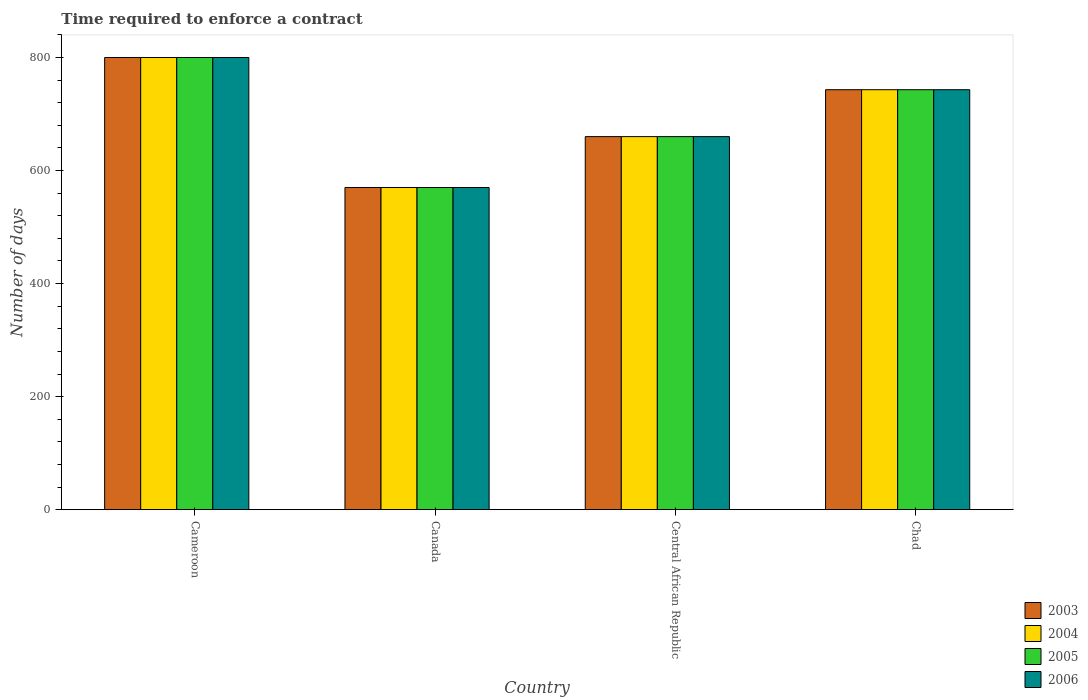How many different coloured bars are there?
Make the answer very short. 4. How many groups of bars are there?
Provide a short and direct response. 4. How many bars are there on the 4th tick from the right?
Provide a short and direct response. 4. What is the label of the 1st group of bars from the left?
Offer a terse response. Cameroon. What is the number of days required to enforce a contract in 2004 in Cameroon?
Provide a succinct answer. 800. Across all countries, what is the maximum number of days required to enforce a contract in 2003?
Give a very brief answer. 800. Across all countries, what is the minimum number of days required to enforce a contract in 2006?
Ensure brevity in your answer.  570. In which country was the number of days required to enforce a contract in 2005 maximum?
Your answer should be very brief. Cameroon. In which country was the number of days required to enforce a contract in 2005 minimum?
Your response must be concise. Canada. What is the total number of days required to enforce a contract in 2006 in the graph?
Ensure brevity in your answer.  2773. What is the difference between the number of days required to enforce a contract in 2006 in Canada and that in Central African Republic?
Keep it short and to the point. -90. What is the difference between the number of days required to enforce a contract in 2003 in Central African Republic and the number of days required to enforce a contract in 2005 in Cameroon?
Give a very brief answer. -140. What is the average number of days required to enforce a contract in 2006 per country?
Keep it short and to the point. 693.25. In how many countries, is the number of days required to enforce a contract in 2004 greater than 560 days?
Offer a terse response. 4. What is the ratio of the number of days required to enforce a contract in 2005 in Cameroon to that in Chad?
Offer a very short reply. 1.08. Is the difference between the number of days required to enforce a contract in 2006 in Cameroon and Canada greater than the difference between the number of days required to enforce a contract in 2004 in Cameroon and Canada?
Your answer should be very brief. No. What is the difference between the highest and the second highest number of days required to enforce a contract in 2005?
Keep it short and to the point. 140. What is the difference between the highest and the lowest number of days required to enforce a contract in 2006?
Your answer should be very brief. 230. In how many countries, is the number of days required to enforce a contract in 2003 greater than the average number of days required to enforce a contract in 2003 taken over all countries?
Ensure brevity in your answer.  2. Is the sum of the number of days required to enforce a contract in 2006 in Cameroon and Chad greater than the maximum number of days required to enforce a contract in 2003 across all countries?
Your response must be concise. Yes. Is it the case that in every country, the sum of the number of days required to enforce a contract in 2003 and number of days required to enforce a contract in 2004 is greater than the sum of number of days required to enforce a contract in 2006 and number of days required to enforce a contract in 2005?
Your answer should be compact. No. What does the 4th bar from the right in Canada represents?
Offer a very short reply. 2003. How many bars are there?
Your answer should be very brief. 16. Are all the bars in the graph horizontal?
Make the answer very short. No. How many countries are there in the graph?
Your answer should be very brief. 4. Does the graph contain grids?
Provide a short and direct response. No. How many legend labels are there?
Offer a very short reply. 4. What is the title of the graph?
Make the answer very short. Time required to enforce a contract. Does "1986" appear as one of the legend labels in the graph?
Offer a terse response. No. What is the label or title of the Y-axis?
Your answer should be very brief. Number of days. What is the Number of days in 2003 in Cameroon?
Your response must be concise. 800. What is the Number of days in 2004 in Cameroon?
Your answer should be compact. 800. What is the Number of days of 2005 in Cameroon?
Offer a very short reply. 800. What is the Number of days of 2006 in Cameroon?
Offer a terse response. 800. What is the Number of days in 2003 in Canada?
Your answer should be compact. 570. What is the Number of days of 2004 in Canada?
Offer a terse response. 570. What is the Number of days in 2005 in Canada?
Provide a succinct answer. 570. What is the Number of days in 2006 in Canada?
Provide a short and direct response. 570. What is the Number of days of 2003 in Central African Republic?
Provide a short and direct response. 660. What is the Number of days of 2004 in Central African Republic?
Ensure brevity in your answer.  660. What is the Number of days of 2005 in Central African Republic?
Give a very brief answer. 660. What is the Number of days of 2006 in Central African Republic?
Provide a short and direct response. 660. What is the Number of days of 2003 in Chad?
Ensure brevity in your answer.  743. What is the Number of days in 2004 in Chad?
Give a very brief answer. 743. What is the Number of days in 2005 in Chad?
Your answer should be compact. 743. What is the Number of days in 2006 in Chad?
Keep it short and to the point. 743. Across all countries, what is the maximum Number of days in 2003?
Offer a very short reply. 800. Across all countries, what is the maximum Number of days in 2004?
Give a very brief answer. 800. Across all countries, what is the maximum Number of days of 2005?
Provide a short and direct response. 800. Across all countries, what is the maximum Number of days of 2006?
Your answer should be compact. 800. Across all countries, what is the minimum Number of days of 2003?
Provide a succinct answer. 570. Across all countries, what is the minimum Number of days in 2004?
Provide a short and direct response. 570. Across all countries, what is the minimum Number of days in 2005?
Give a very brief answer. 570. Across all countries, what is the minimum Number of days of 2006?
Offer a very short reply. 570. What is the total Number of days of 2003 in the graph?
Your response must be concise. 2773. What is the total Number of days of 2004 in the graph?
Keep it short and to the point. 2773. What is the total Number of days in 2005 in the graph?
Make the answer very short. 2773. What is the total Number of days in 2006 in the graph?
Make the answer very short. 2773. What is the difference between the Number of days of 2003 in Cameroon and that in Canada?
Your answer should be compact. 230. What is the difference between the Number of days in 2004 in Cameroon and that in Canada?
Make the answer very short. 230. What is the difference between the Number of days of 2005 in Cameroon and that in Canada?
Provide a succinct answer. 230. What is the difference between the Number of days in 2006 in Cameroon and that in Canada?
Your answer should be very brief. 230. What is the difference between the Number of days of 2003 in Cameroon and that in Central African Republic?
Offer a terse response. 140. What is the difference between the Number of days in 2004 in Cameroon and that in Central African Republic?
Keep it short and to the point. 140. What is the difference between the Number of days in 2005 in Cameroon and that in Central African Republic?
Make the answer very short. 140. What is the difference between the Number of days of 2006 in Cameroon and that in Central African Republic?
Offer a terse response. 140. What is the difference between the Number of days in 2003 in Cameroon and that in Chad?
Provide a succinct answer. 57. What is the difference between the Number of days of 2004 in Cameroon and that in Chad?
Your answer should be compact. 57. What is the difference between the Number of days of 2003 in Canada and that in Central African Republic?
Provide a short and direct response. -90. What is the difference between the Number of days in 2004 in Canada and that in Central African Republic?
Your answer should be compact. -90. What is the difference between the Number of days of 2005 in Canada and that in Central African Republic?
Offer a very short reply. -90. What is the difference between the Number of days in 2006 in Canada and that in Central African Republic?
Make the answer very short. -90. What is the difference between the Number of days of 2003 in Canada and that in Chad?
Keep it short and to the point. -173. What is the difference between the Number of days in 2004 in Canada and that in Chad?
Offer a terse response. -173. What is the difference between the Number of days of 2005 in Canada and that in Chad?
Give a very brief answer. -173. What is the difference between the Number of days of 2006 in Canada and that in Chad?
Ensure brevity in your answer.  -173. What is the difference between the Number of days of 2003 in Central African Republic and that in Chad?
Provide a short and direct response. -83. What is the difference between the Number of days in 2004 in Central African Republic and that in Chad?
Offer a terse response. -83. What is the difference between the Number of days in 2005 in Central African Republic and that in Chad?
Provide a succinct answer. -83. What is the difference between the Number of days in 2006 in Central African Republic and that in Chad?
Offer a terse response. -83. What is the difference between the Number of days in 2003 in Cameroon and the Number of days in 2004 in Canada?
Offer a terse response. 230. What is the difference between the Number of days in 2003 in Cameroon and the Number of days in 2005 in Canada?
Your answer should be very brief. 230. What is the difference between the Number of days in 2003 in Cameroon and the Number of days in 2006 in Canada?
Offer a terse response. 230. What is the difference between the Number of days in 2004 in Cameroon and the Number of days in 2005 in Canada?
Keep it short and to the point. 230. What is the difference between the Number of days of 2004 in Cameroon and the Number of days of 2006 in Canada?
Your answer should be very brief. 230. What is the difference between the Number of days of 2005 in Cameroon and the Number of days of 2006 in Canada?
Provide a short and direct response. 230. What is the difference between the Number of days of 2003 in Cameroon and the Number of days of 2004 in Central African Republic?
Make the answer very short. 140. What is the difference between the Number of days of 2003 in Cameroon and the Number of days of 2005 in Central African Republic?
Offer a very short reply. 140. What is the difference between the Number of days of 2003 in Cameroon and the Number of days of 2006 in Central African Republic?
Offer a very short reply. 140. What is the difference between the Number of days of 2004 in Cameroon and the Number of days of 2005 in Central African Republic?
Make the answer very short. 140. What is the difference between the Number of days in 2004 in Cameroon and the Number of days in 2006 in Central African Republic?
Make the answer very short. 140. What is the difference between the Number of days of 2005 in Cameroon and the Number of days of 2006 in Central African Republic?
Your answer should be very brief. 140. What is the difference between the Number of days of 2003 in Cameroon and the Number of days of 2005 in Chad?
Give a very brief answer. 57. What is the difference between the Number of days of 2003 in Cameroon and the Number of days of 2006 in Chad?
Provide a succinct answer. 57. What is the difference between the Number of days of 2005 in Cameroon and the Number of days of 2006 in Chad?
Keep it short and to the point. 57. What is the difference between the Number of days of 2003 in Canada and the Number of days of 2004 in Central African Republic?
Offer a terse response. -90. What is the difference between the Number of days of 2003 in Canada and the Number of days of 2005 in Central African Republic?
Your answer should be compact. -90. What is the difference between the Number of days of 2003 in Canada and the Number of days of 2006 in Central African Republic?
Provide a succinct answer. -90. What is the difference between the Number of days in 2004 in Canada and the Number of days in 2005 in Central African Republic?
Make the answer very short. -90. What is the difference between the Number of days of 2004 in Canada and the Number of days of 2006 in Central African Republic?
Your answer should be very brief. -90. What is the difference between the Number of days of 2005 in Canada and the Number of days of 2006 in Central African Republic?
Give a very brief answer. -90. What is the difference between the Number of days of 2003 in Canada and the Number of days of 2004 in Chad?
Offer a very short reply. -173. What is the difference between the Number of days of 2003 in Canada and the Number of days of 2005 in Chad?
Provide a succinct answer. -173. What is the difference between the Number of days in 2003 in Canada and the Number of days in 2006 in Chad?
Give a very brief answer. -173. What is the difference between the Number of days in 2004 in Canada and the Number of days in 2005 in Chad?
Your response must be concise. -173. What is the difference between the Number of days in 2004 in Canada and the Number of days in 2006 in Chad?
Your answer should be compact. -173. What is the difference between the Number of days of 2005 in Canada and the Number of days of 2006 in Chad?
Provide a succinct answer. -173. What is the difference between the Number of days in 2003 in Central African Republic and the Number of days in 2004 in Chad?
Your response must be concise. -83. What is the difference between the Number of days of 2003 in Central African Republic and the Number of days of 2005 in Chad?
Offer a very short reply. -83. What is the difference between the Number of days in 2003 in Central African Republic and the Number of days in 2006 in Chad?
Provide a succinct answer. -83. What is the difference between the Number of days of 2004 in Central African Republic and the Number of days of 2005 in Chad?
Make the answer very short. -83. What is the difference between the Number of days of 2004 in Central African Republic and the Number of days of 2006 in Chad?
Provide a short and direct response. -83. What is the difference between the Number of days in 2005 in Central African Republic and the Number of days in 2006 in Chad?
Offer a terse response. -83. What is the average Number of days of 2003 per country?
Your answer should be very brief. 693.25. What is the average Number of days of 2004 per country?
Your response must be concise. 693.25. What is the average Number of days in 2005 per country?
Make the answer very short. 693.25. What is the average Number of days in 2006 per country?
Ensure brevity in your answer.  693.25. What is the difference between the Number of days of 2004 and Number of days of 2006 in Cameroon?
Provide a short and direct response. 0. What is the difference between the Number of days in 2003 and Number of days in 2004 in Canada?
Provide a succinct answer. 0. What is the difference between the Number of days of 2003 and Number of days of 2005 in Canada?
Your answer should be very brief. 0. What is the difference between the Number of days in 2003 and Number of days in 2006 in Canada?
Provide a short and direct response. 0. What is the difference between the Number of days of 2004 and Number of days of 2005 in Canada?
Provide a succinct answer. 0. What is the difference between the Number of days in 2004 and Number of days in 2006 in Canada?
Your response must be concise. 0. What is the difference between the Number of days in 2003 and Number of days in 2005 in Central African Republic?
Your answer should be very brief. 0. What is the difference between the Number of days in 2004 and Number of days in 2005 in Central African Republic?
Make the answer very short. 0. What is the difference between the Number of days of 2004 and Number of days of 2006 in Central African Republic?
Your answer should be compact. 0. What is the difference between the Number of days of 2005 and Number of days of 2006 in Central African Republic?
Provide a short and direct response. 0. What is the difference between the Number of days of 2003 and Number of days of 2004 in Chad?
Your answer should be very brief. 0. What is the difference between the Number of days in 2003 and Number of days in 2006 in Chad?
Your response must be concise. 0. What is the difference between the Number of days in 2004 and Number of days in 2005 in Chad?
Provide a succinct answer. 0. What is the difference between the Number of days in 2005 and Number of days in 2006 in Chad?
Provide a succinct answer. 0. What is the ratio of the Number of days of 2003 in Cameroon to that in Canada?
Offer a terse response. 1.4. What is the ratio of the Number of days in 2004 in Cameroon to that in Canada?
Provide a short and direct response. 1.4. What is the ratio of the Number of days of 2005 in Cameroon to that in Canada?
Ensure brevity in your answer.  1.4. What is the ratio of the Number of days of 2006 in Cameroon to that in Canada?
Your answer should be compact. 1.4. What is the ratio of the Number of days of 2003 in Cameroon to that in Central African Republic?
Keep it short and to the point. 1.21. What is the ratio of the Number of days of 2004 in Cameroon to that in Central African Republic?
Offer a very short reply. 1.21. What is the ratio of the Number of days of 2005 in Cameroon to that in Central African Republic?
Make the answer very short. 1.21. What is the ratio of the Number of days in 2006 in Cameroon to that in Central African Republic?
Ensure brevity in your answer.  1.21. What is the ratio of the Number of days in 2003 in Cameroon to that in Chad?
Your response must be concise. 1.08. What is the ratio of the Number of days in 2004 in Cameroon to that in Chad?
Your answer should be compact. 1.08. What is the ratio of the Number of days in 2005 in Cameroon to that in Chad?
Give a very brief answer. 1.08. What is the ratio of the Number of days in 2006 in Cameroon to that in Chad?
Offer a terse response. 1.08. What is the ratio of the Number of days of 2003 in Canada to that in Central African Republic?
Your response must be concise. 0.86. What is the ratio of the Number of days of 2004 in Canada to that in Central African Republic?
Keep it short and to the point. 0.86. What is the ratio of the Number of days of 2005 in Canada to that in Central African Republic?
Keep it short and to the point. 0.86. What is the ratio of the Number of days in 2006 in Canada to that in Central African Republic?
Your answer should be compact. 0.86. What is the ratio of the Number of days in 2003 in Canada to that in Chad?
Make the answer very short. 0.77. What is the ratio of the Number of days of 2004 in Canada to that in Chad?
Give a very brief answer. 0.77. What is the ratio of the Number of days in 2005 in Canada to that in Chad?
Give a very brief answer. 0.77. What is the ratio of the Number of days of 2006 in Canada to that in Chad?
Give a very brief answer. 0.77. What is the ratio of the Number of days in 2003 in Central African Republic to that in Chad?
Offer a terse response. 0.89. What is the ratio of the Number of days in 2004 in Central African Republic to that in Chad?
Provide a succinct answer. 0.89. What is the ratio of the Number of days of 2005 in Central African Republic to that in Chad?
Your response must be concise. 0.89. What is the ratio of the Number of days of 2006 in Central African Republic to that in Chad?
Your answer should be very brief. 0.89. What is the difference between the highest and the second highest Number of days of 2006?
Provide a succinct answer. 57. What is the difference between the highest and the lowest Number of days of 2003?
Your answer should be compact. 230. What is the difference between the highest and the lowest Number of days of 2004?
Provide a short and direct response. 230. What is the difference between the highest and the lowest Number of days in 2005?
Your answer should be very brief. 230. What is the difference between the highest and the lowest Number of days in 2006?
Keep it short and to the point. 230. 